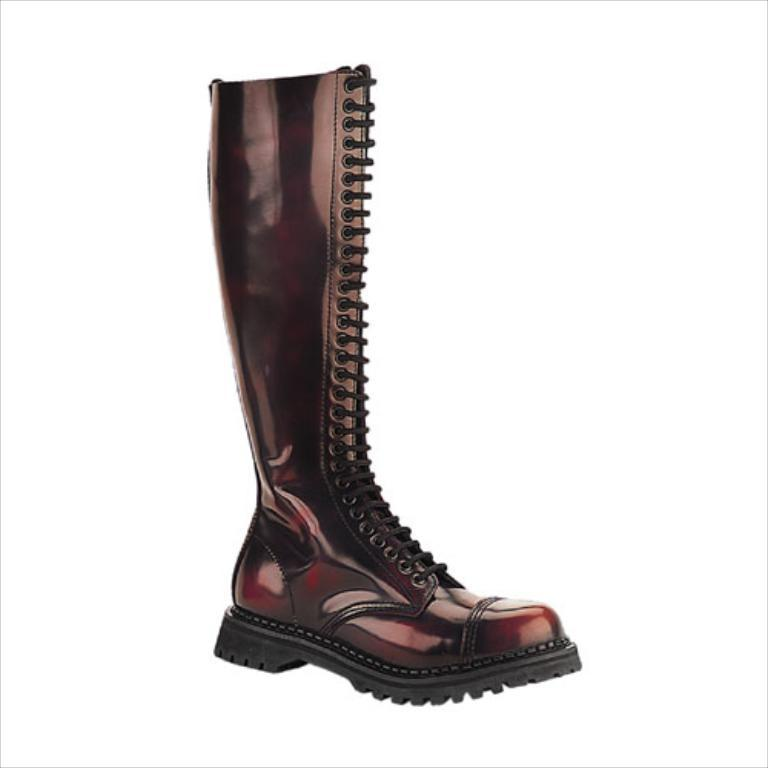What object is located in the foreground of the image? There is a gumboot in the foreground of the image. What type of prose is being recited by the gumboot in the image? There is no indication in the image that the gumboot is reciting any prose, as gumboots are inanimate objects and cannot speak or recite literature. 